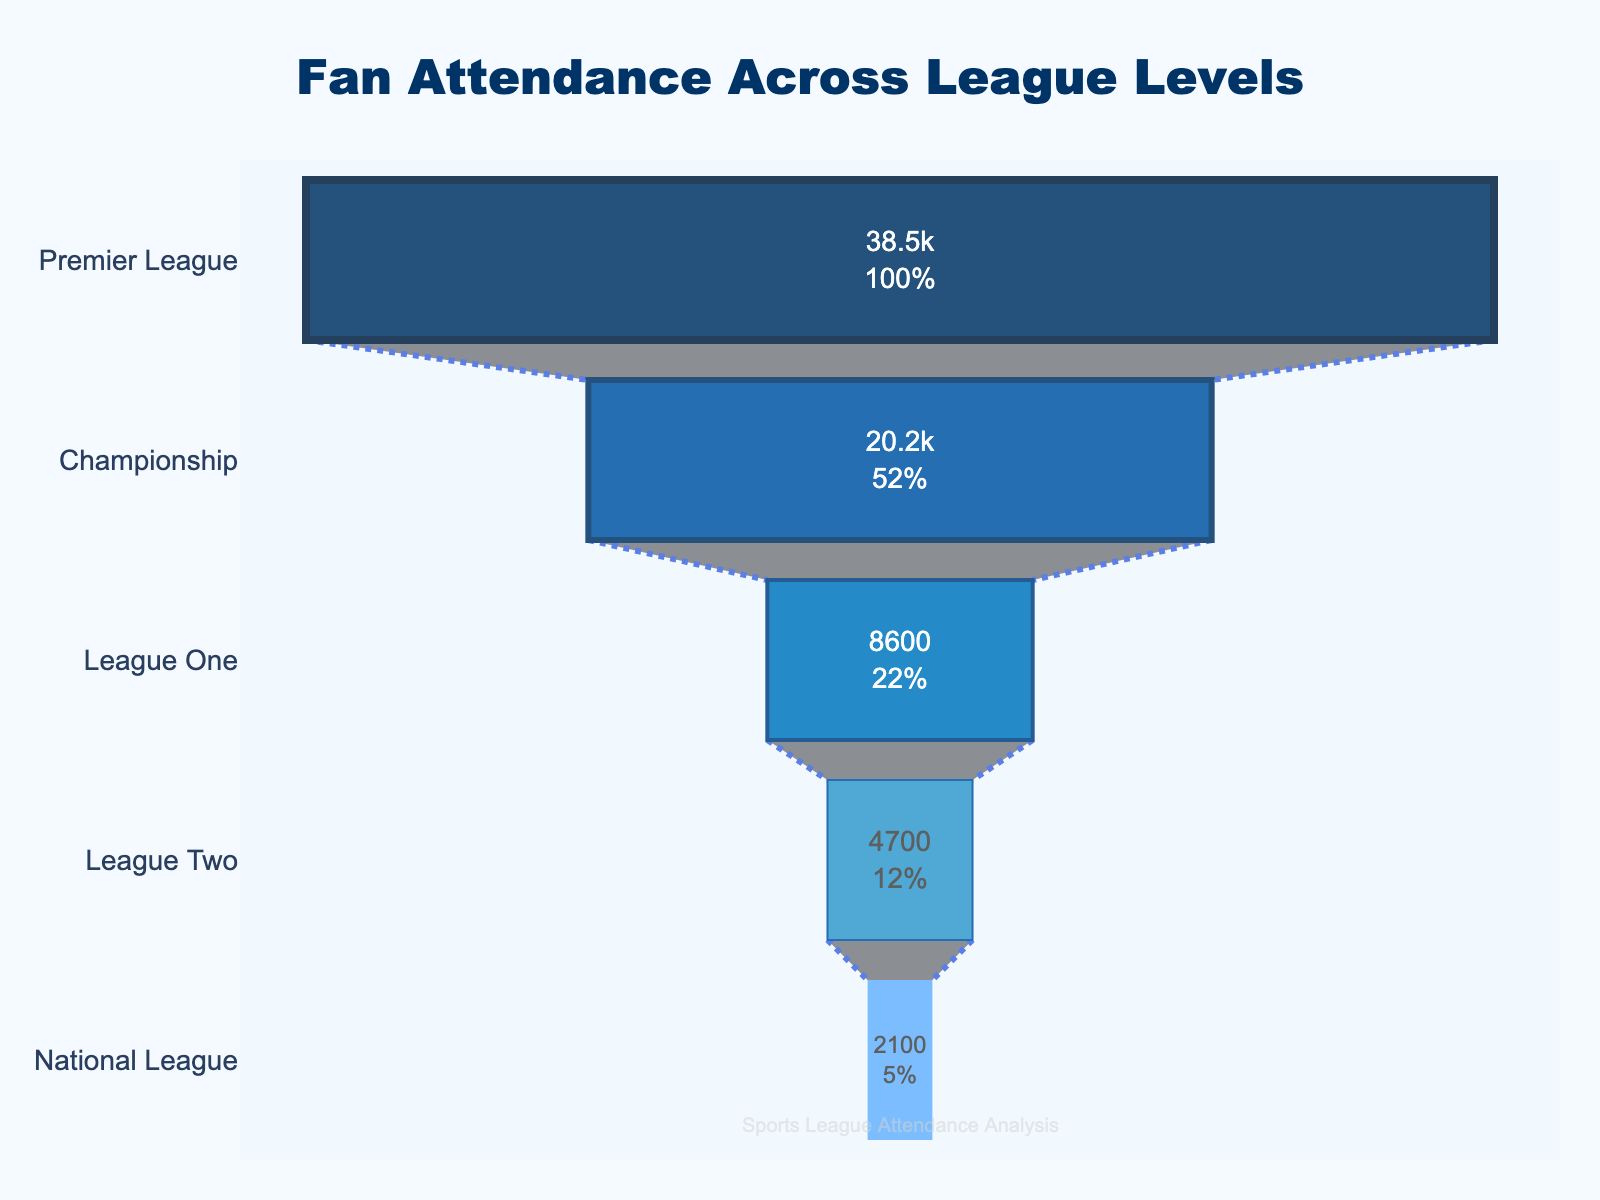What's the title of the funnel chart? The title of the funnel chart is located at the top of the chart area and is typically written in a larger font than the other text.
Answer: Fan Attendance Across League Levels How many league levels are represented in the chart? To determine how many league levels are represented, count the number of unique entries listed along the y-axis.
Answer: 5 Which league level has the highest average attendance? From top to bottom, the first entry in the funnel represents the highest average attendance.
Answer: Premier League What is the color used for the "League One" section? Identify the associated section labeled "League One" and observe its color.
Answer: Light blue What is the percentage of fan attendance at the Championship level compared to the Premier League? Locate the values for both Championship and Premier League. Compute the percentage by dividing Championship attendance (20200) by Premier League attendance (38500) and multiply by 100.
Answer: 52.47% Find the difference in average attendance between the Premier League and League Two. Subtract the average attendance of League Two (4700) from that of the Premier League (38500).
Answer: 33800 Which level has the lowest average attendance, and what is that value? The lowest section of the funnel chart represents the level with the lowest average attendance.
Answer: National League, 2100 Compare the average attendances of League One and League Two. Which is higher and by how much? Determine the average attendances of League One (8600) and League Two (4700), then subtract the latter from the former and note which is higher.
Answer: League One by 3900 What is the sum of the average attendances of all league levels? Add the average attendance values of all league levels: 38500 + 20200 + 8600 + 4700 + 2100.
Answer: 74100 Estimate the median average attendance value across the league levels. List the average attendance values in ascending order: 2100, 4700, 8600, 20200, 38500. The median is the middle value.
Answer: 8600 